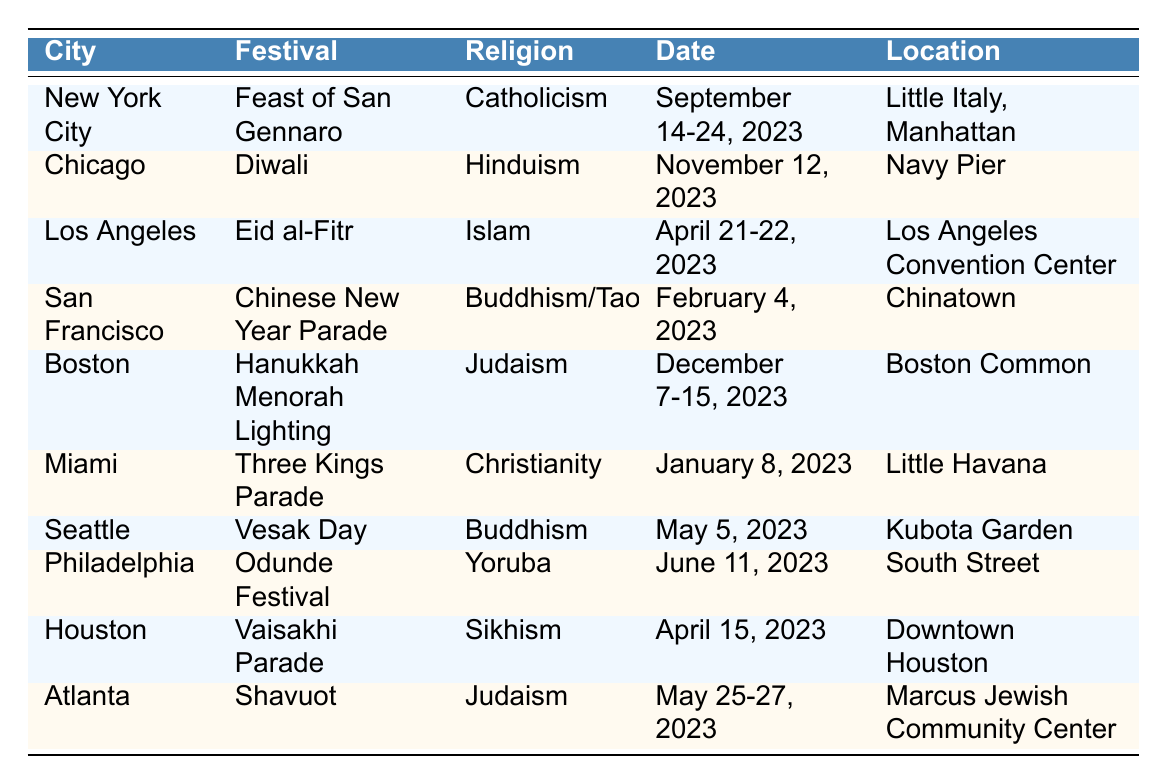What is the date of the Diwali festival in Chicago? The table lists the date for the Diwali festival in Chicago as November 12, 2023.
Answer: November 12, 2023 Which city hosts the Hanukkah Menorah Lighting? Looking at the table, Boston is the city where the Hanukkah Menorah Lighting festival takes place.
Answer: Boston Is the Feast of San Gennaro related to Judaism? The table shows that the Feast of San Gennaro is related to Catholicism, not Judaism, making this statement false.
Answer: No How many festivals occur in May 2023? The table lists two festivals in May 2023: Vesak Day and Shavuot, totaling to two festivals.
Answer: 2 What religion is associated with the Three Kings Parade? From the table, Christianity is the religion associated with the Three Kings Parade festival.
Answer: Christianity In which city and location does Eid al-Fitr take place? The table indicates that Eid al-Fitr occurs in Los Angeles at the Los Angeles Convention Center.
Answer: Los Angeles, Los Angeles Convention Center How many days does the Eid al-Fitr festival last? The table shows that Eid al-Fitr lasts for 2 days, specifically on April 21 and April 22, 2023.
Answer: 2 days Which city has two different festivals that feature Buddhism? According to the table, San Francisco and Seattle each have festivals related to Buddhism: Chinese New Year Parade and Vesak Day, respectively.
Answer: San Francisco and Seattle Is there a festival dedicated to Sikhism in the table? The Vaisakhi Parade is explicitly stated as a festival dedicated to Sikhism, confirming that there is a Sikh festival mentioned.
Answer: Yes Which festival occurs last in the year? By examining the dates, the Hanukkah Menorah Lighting in Boston occurring from December 7-15, 2023 is the last festival in the table.
Answer: Hanukkah Menorah Lighting 